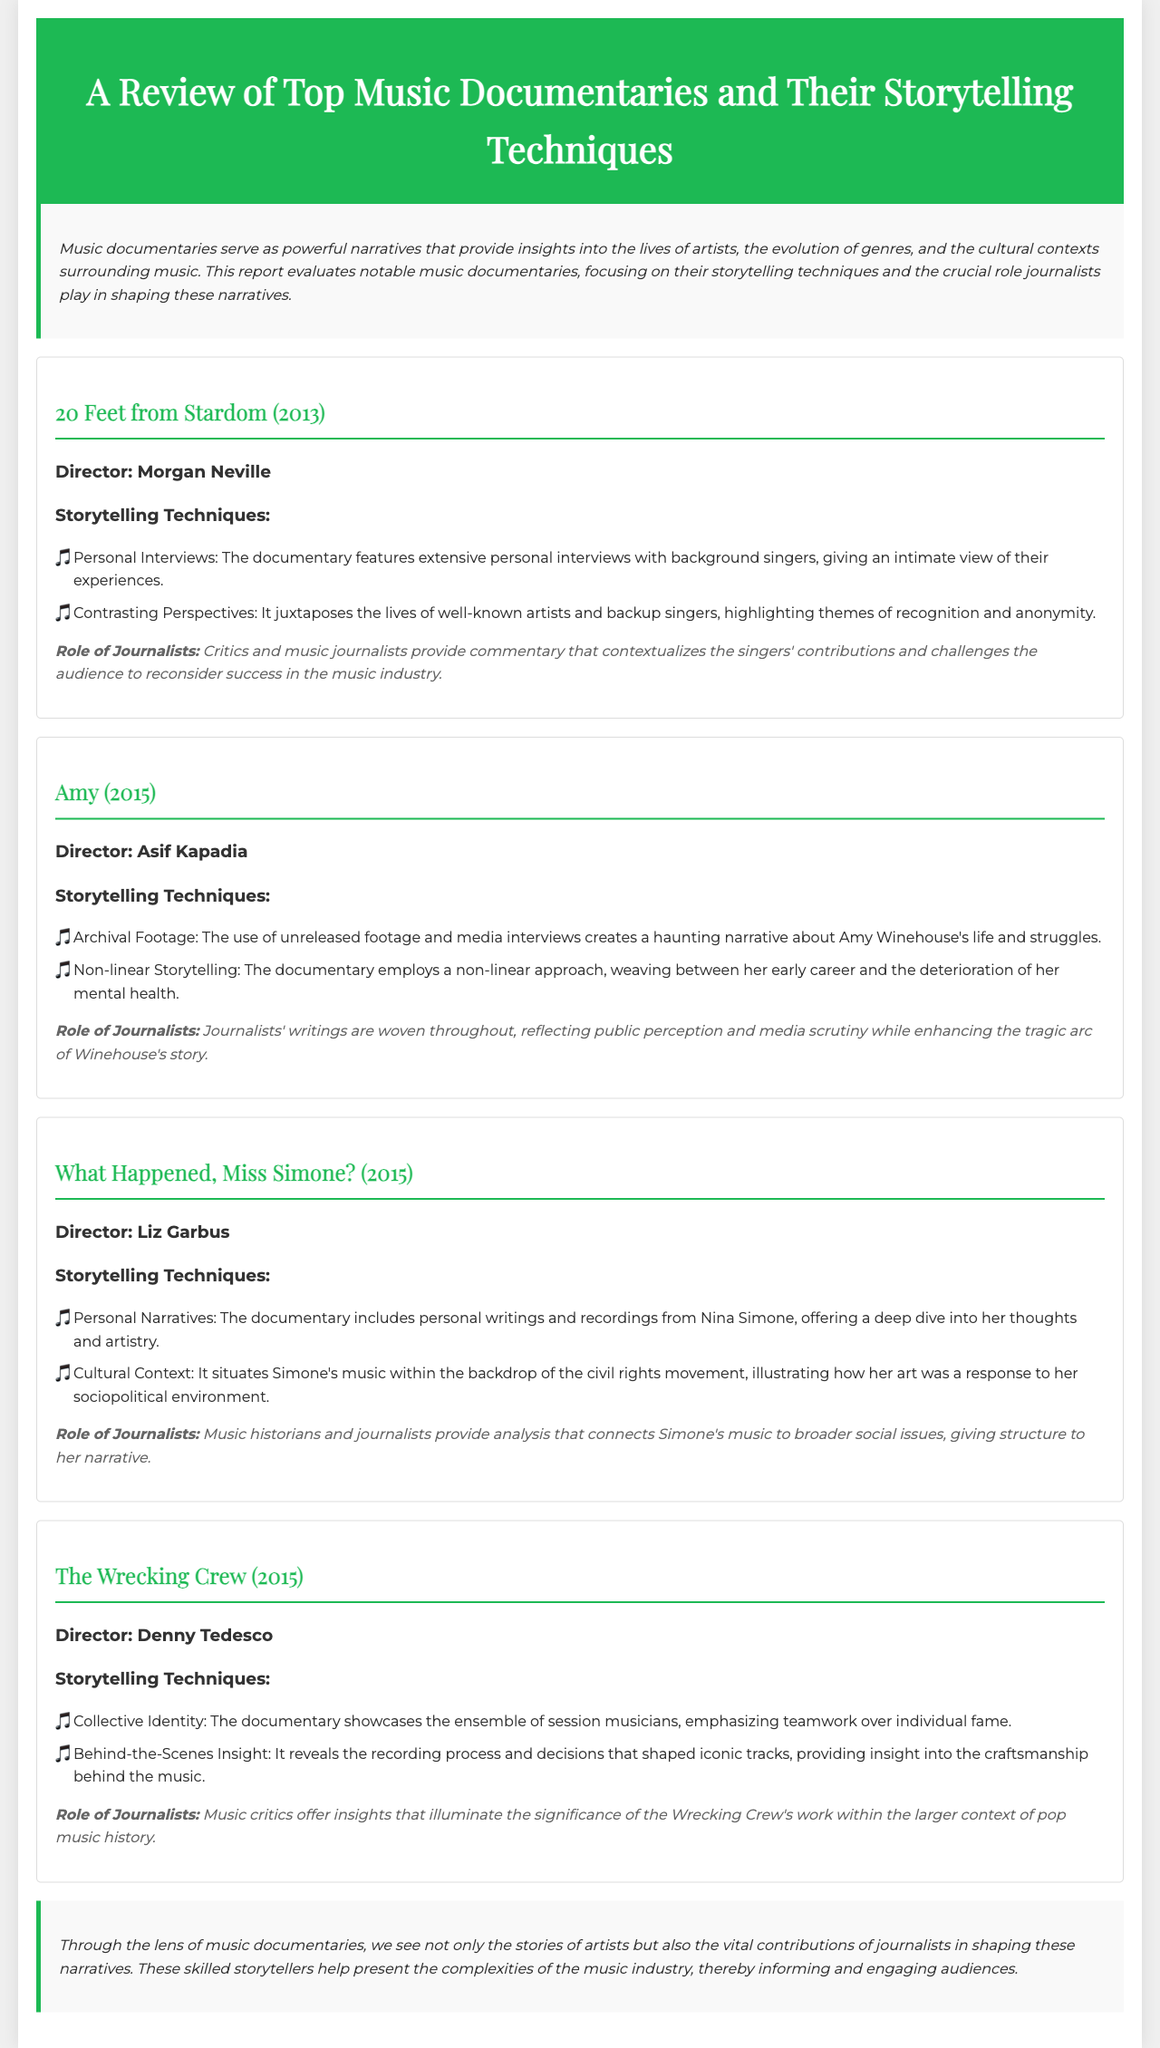What is the title of the first documentary reviewed? The title of the first documentary is mentioned at the beginning of its section in the report.
Answer: 20 Feet from Stardom Who directed the documentary "Amy"? The director's name is provided in the information about the documentary "Amy".
Answer: Asif Kapadia What storytelling technique is used in "What Happened, Miss Simone?"? The report lists specific storytelling techniques used in each documentary, including the one for "What Happened, Miss Simone?".
Answer: Personal Narratives Which documentary highlights the lives of backup singers? The documentary that focuses on backup singers is explicitly mentioned in the title of its section.
Answer: 20 Feet from Stardom How many documentaries are reviewed in total? The introduction and the structure of the report indicate the number of documentaries discussed.
Answer: Four What role do journalists play in the documentaries according to the report? The explanation of journalists’ contributions appears in the context of each documentary's storytelling techniques.
Answer: Commentary What year was "The Wrecking Crew" released? The release year is indicated at the beginning of the documentary section in the report.
Answer: 2015 What is a common theme discussed across the documentaries? The report discusses various themes related to the music industry across the analyses of the different documentaries.
Answer: Recognition Which documentary uses archival footage? The technique of archival footage is mentioned specifically in the explanation of one of the documentaries.
Answer: Amy 